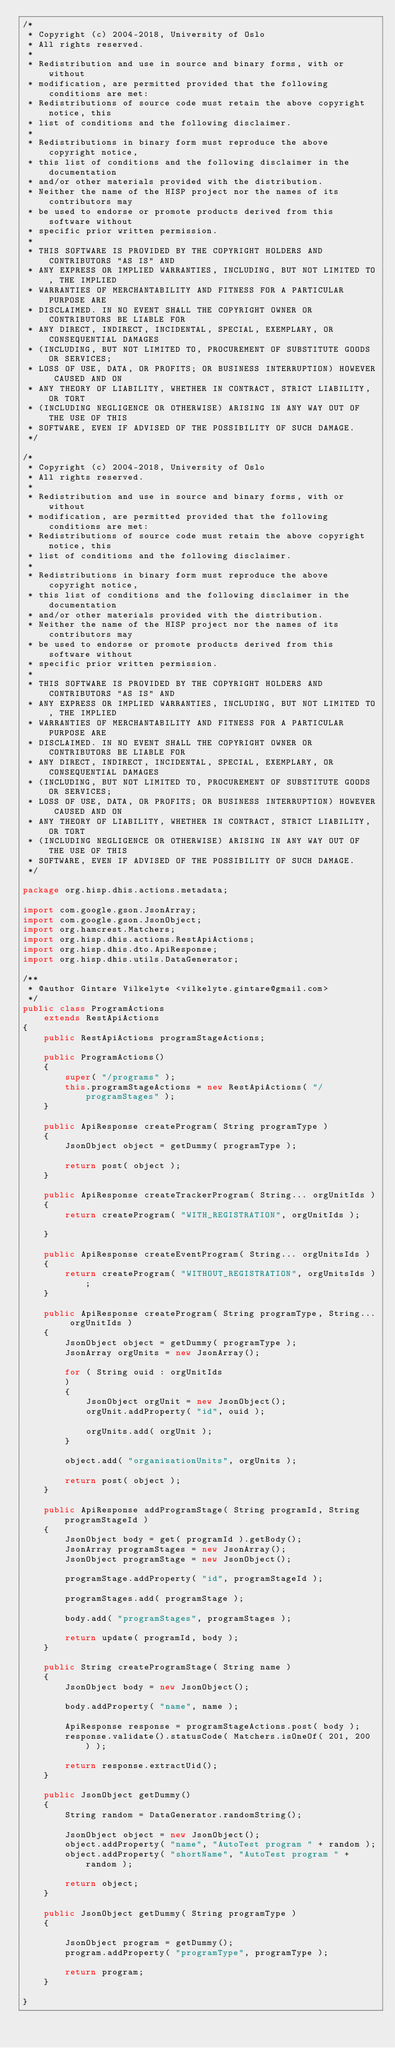Convert code to text. <code><loc_0><loc_0><loc_500><loc_500><_Java_>/*
 * Copyright (c) 2004-2018, University of Oslo
 * All rights reserved.
 *
 * Redistribution and use in source and binary forms, with or without
 * modification, are permitted provided that the following conditions are met:
 * Redistributions of source code must retain the above copyright notice, this
 * list of conditions and the following disclaimer.
 *
 * Redistributions in binary form must reproduce the above copyright notice,
 * this list of conditions and the following disclaimer in the documentation
 * and/or other materials provided with the distribution.
 * Neither the name of the HISP project nor the names of its contributors may
 * be used to endorse or promote products derived from this software without
 * specific prior written permission.
 *
 * THIS SOFTWARE IS PROVIDED BY THE COPYRIGHT HOLDERS AND CONTRIBUTORS "AS IS" AND
 * ANY EXPRESS OR IMPLIED WARRANTIES, INCLUDING, BUT NOT LIMITED TO, THE IMPLIED
 * WARRANTIES OF MERCHANTABILITY AND FITNESS FOR A PARTICULAR PURPOSE ARE
 * DISCLAIMED. IN NO EVENT SHALL THE COPYRIGHT OWNER OR CONTRIBUTORS BE LIABLE FOR
 * ANY DIRECT, INDIRECT, INCIDENTAL, SPECIAL, EXEMPLARY, OR CONSEQUENTIAL DAMAGES
 * (INCLUDING, BUT NOT LIMITED TO, PROCUREMENT OF SUBSTITUTE GOODS OR SERVICES;
 * LOSS OF USE, DATA, OR PROFITS; OR BUSINESS INTERRUPTION) HOWEVER CAUSED AND ON
 * ANY THEORY OF LIABILITY, WHETHER IN CONTRACT, STRICT LIABILITY, OR TORT
 * (INCLUDING NEGLIGENCE OR OTHERWISE) ARISING IN ANY WAY OUT OF THE USE OF THIS
 * SOFTWARE, EVEN IF ADVISED OF THE POSSIBILITY OF SUCH DAMAGE.
 */

/*
 * Copyright (c) 2004-2018, University of Oslo
 * All rights reserved.
 *
 * Redistribution and use in source and binary forms, with or without
 * modification, are permitted provided that the following conditions are met:
 * Redistributions of source code must retain the above copyright notice, this
 * list of conditions and the following disclaimer.
 *
 * Redistributions in binary form must reproduce the above copyright notice,
 * this list of conditions and the following disclaimer in the documentation
 * and/or other materials provided with the distribution.
 * Neither the name of the HISP project nor the names of its contributors may
 * be used to endorse or promote products derived from this software without
 * specific prior written permission.
 *
 * THIS SOFTWARE IS PROVIDED BY THE COPYRIGHT HOLDERS AND CONTRIBUTORS "AS IS" AND
 * ANY EXPRESS OR IMPLIED WARRANTIES, INCLUDING, BUT NOT LIMITED TO, THE IMPLIED
 * WARRANTIES OF MERCHANTABILITY AND FITNESS FOR A PARTICULAR PURPOSE ARE
 * DISCLAIMED. IN NO EVENT SHALL THE COPYRIGHT OWNER OR CONTRIBUTORS BE LIABLE FOR
 * ANY DIRECT, INDIRECT, INCIDENTAL, SPECIAL, EXEMPLARY, OR CONSEQUENTIAL DAMAGES
 * (INCLUDING, BUT NOT LIMITED TO, PROCUREMENT OF SUBSTITUTE GOODS OR SERVICES;
 * LOSS OF USE, DATA, OR PROFITS; OR BUSINESS INTERRUPTION) HOWEVER CAUSED AND ON
 * ANY THEORY OF LIABILITY, WHETHER IN CONTRACT, STRICT LIABILITY, OR TORT
 * (INCLUDING NEGLIGENCE OR OTHERWISE) ARISING IN ANY WAY OUT OF THE USE OF THIS
 * SOFTWARE, EVEN IF ADVISED OF THE POSSIBILITY OF SUCH DAMAGE.
 */

package org.hisp.dhis.actions.metadata;

import com.google.gson.JsonArray;
import com.google.gson.JsonObject;
import org.hamcrest.Matchers;
import org.hisp.dhis.actions.RestApiActions;
import org.hisp.dhis.dto.ApiResponse;
import org.hisp.dhis.utils.DataGenerator;

/**
 * @author Gintare Vilkelyte <vilkelyte.gintare@gmail.com>
 */
public class ProgramActions
    extends RestApiActions
{
    public RestApiActions programStageActions;

    public ProgramActions()
    {
        super( "/programs" );
        this.programStageActions = new RestApiActions( "/programStages" );
    }

    public ApiResponse createProgram( String programType )
    {
        JsonObject object = getDummy( programType );

        return post( object );
    }

    public ApiResponse createTrackerProgram( String... orgUnitIds )
    {
        return createProgram( "WITH_REGISTRATION", orgUnitIds );

    }

    public ApiResponse createEventProgram( String... orgUnitsIds )
    {
        return createProgram( "WITHOUT_REGISTRATION", orgUnitsIds );
    }

    public ApiResponse createProgram( String programType, String... orgUnitIds )
    {
        JsonObject object = getDummy( programType );
        JsonArray orgUnits = new JsonArray();

        for ( String ouid : orgUnitIds
        )
        {
            JsonObject orgUnit = new JsonObject();
            orgUnit.addProperty( "id", ouid );

            orgUnits.add( orgUnit );
        }

        object.add( "organisationUnits", orgUnits );

        return post( object );
    }

    public ApiResponse addProgramStage( String programId, String programStageId )
    {
        JsonObject body = get( programId ).getBody();
        JsonArray programStages = new JsonArray();
        JsonObject programStage = new JsonObject();

        programStage.addProperty( "id", programStageId );

        programStages.add( programStage );

        body.add( "programStages", programStages );

        return update( programId, body );
    }

    public String createProgramStage( String name )
    {
        JsonObject body = new JsonObject();

        body.addProperty( "name", name );

        ApiResponse response = programStageActions.post( body );
        response.validate().statusCode( Matchers.isOneOf( 201, 200 ) );

        return response.extractUid();
    }

    public JsonObject getDummy()
    {
        String random = DataGenerator.randomString();

        JsonObject object = new JsonObject();
        object.addProperty( "name", "AutoTest program " + random );
        object.addProperty( "shortName", "AutoTest program " + random );

        return object;
    }

    public JsonObject getDummy( String programType )
    {

        JsonObject program = getDummy();
        program.addProperty( "programType", programType );

        return program;
    }

}
</code> 